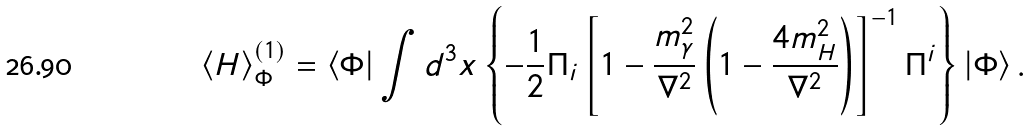Convert formula to latex. <formula><loc_0><loc_0><loc_500><loc_500>\left \langle H \right \rangle _ { \Phi } ^ { \left ( 1 \right ) } = \left \langle \Phi \right | \int { d ^ { 3 } x } \left \{ { - \frac { 1 } { 2 } \Pi _ { i } \left [ { 1 - \frac { m _ { \gamma } ^ { 2 } } { \nabla ^ { 2 } } \left ( { 1 - \frac { 4 m _ { H } ^ { 2 } } { \nabla ^ { 2 } } } \right ) } \right ] ^ { - 1 } \Pi ^ { i } } \right \} \left | \Phi \right \rangle .</formula> 